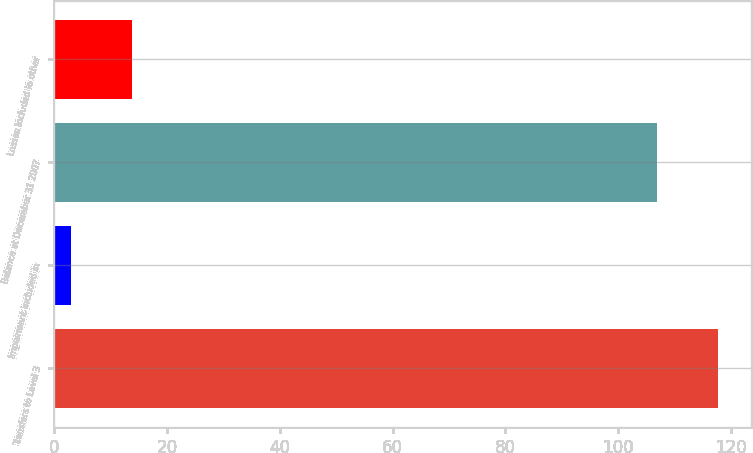Convert chart to OTSL. <chart><loc_0><loc_0><loc_500><loc_500><bar_chart><fcel>Transfers to Level 3<fcel>Impairment included in<fcel>Balance at December 31 2007<fcel>Losses included in other<nl><fcel>117.7<fcel>3<fcel>107<fcel>13.7<nl></chart> 